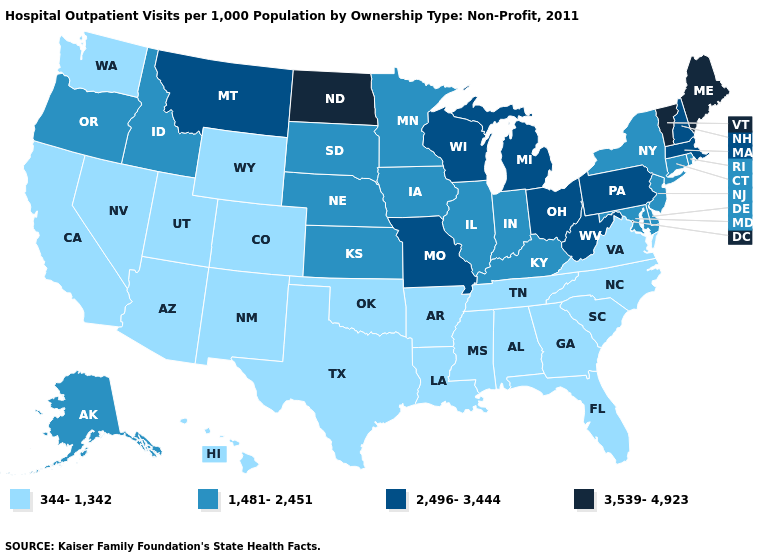What is the value of Montana?
Keep it brief. 2,496-3,444. Name the states that have a value in the range 344-1,342?
Answer briefly. Alabama, Arizona, Arkansas, California, Colorado, Florida, Georgia, Hawaii, Louisiana, Mississippi, Nevada, New Mexico, North Carolina, Oklahoma, South Carolina, Tennessee, Texas, Utah, Virginia, Washington, Wyoming. Name the states that have a value in the range 344-1,342?
Keep it brief. Alabama, Arizona, Arkansas, California, Colorado, Florida, Georgia, Hawaii, Louisiana, Mississippi, Nevada, New Mexico, North Carolina, Oklahoma, South Carolina, Tennessee, Texas, Utah, Virginia, Washington, Wyoming. Does the first symbol in the legend represent the smallest category?
Keep it brief. Yes. Among the states that border Arizona , which have the highest value?
Write a very short answer. California, Colorado, Nevada, New Mexico, Utah. Name the states that have a value in the range 3,539-4,923?
Answer briefly. Maine, North Dakota, Vermont. Does the map have missing data?
Quick response, please. No. Name the states that have a value in the range 3,539-4,923?
Quick response, please. Maine, North Dakota, Vermont. Does Oregon have a lower value than Michigan?
Keep it brief. Yes. What is the lowest value in the South?
Concise answer only. 344-1,342. How many symbols are there in the legend?
Answer briefly. 4. Name the states that have a value in the range 344-1,342?
Quick response, please. Alabama, Arizona, Arkansas, California, Colorado, Florida, Georgia, Hawaii, Louisiana, Mississippi, Nevada, New Mexico, North Carolina, Oklahoma, South Carolina, Tennessee, Texas, Utah, Virginia, Washington, Wyoming. What is the value of Virginia?
Give a very brief answer. 344-1,342. Name the states that have a value in the range 344-1,342?
Write a very short answer. Alabama, Arizona, Arkansas, California, Colorado, Florida, Georgia, Hawaii, Louisiana, Mississippi, Nevada, New Mexico, North Carolina, Oklahoma, South Carolina, Tennessee, Texas, Utah, Virginia, Washington, Wyoming. Name the states that have a value in the range 344-1,342?
Be succinct. Alabama, Arizona, Arkansas, California, Colorado, Florida, Georgia, Hawaii, Louisiana, Mississippi, Nevada, New Mexico, North Carolina, Oklahoma, South Carolina, Tennessee, Texas, Utah, Virginia, Washington, Wyoming. 